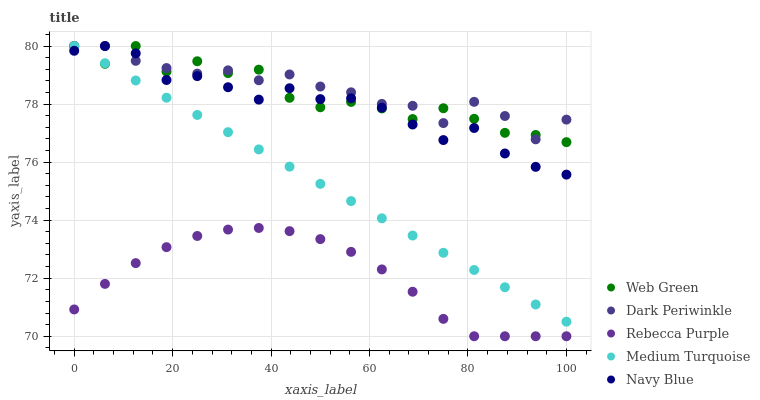Does Rebecca Purple have the minimum area under the curve?
Answer yes or no. Yes. Does Dark Periwinkle have the maximum area under the curve?
Answer yes or no. Yes. Does Medium Turquoise have the minimum area under the curve?
Answer yes or no. No. Does Medium Turquoise have the maximum area under the curve?
Answer yes or no. No. Is Medium Turquoise the smoothest?
Answer yes or no. Yes. Is Web Green the roughest?
Answer yes or no. Yes. Is Dark Periwinkle the smoothest?
Answer yes or no. No. Is Dark Periwinkle the roughest?
Answer yes or no. No. Does Rebecca Purple have the lowest value?
Answer yes or no. Yes. Does Medium Turquoise have the lowest value?
Answer yes or no. No. Does Web Green have the highest value?
Answer yes or no. Yes. Does Rebecca Purple have the highest value?
Answer yes or no. No. Is Rebecca Purple less than Medium Turquoise?
Answer yes or no. Yes. Is Medium Turquoise greater than Rebecca Purple?
Answer yes or no. Yes. Does Dark Periwinkle intersect Navy Blue?
Answer yes or no. Yes. Is Dark Periwinkle less than Navy Blue?
Answer yes or no. No. Is Dark Periwinkle greater than Navy Blue?
Answer yes or no. No. Does Rebecca Purple intersect Medium Turquoise?
Answer yes or no. No. 